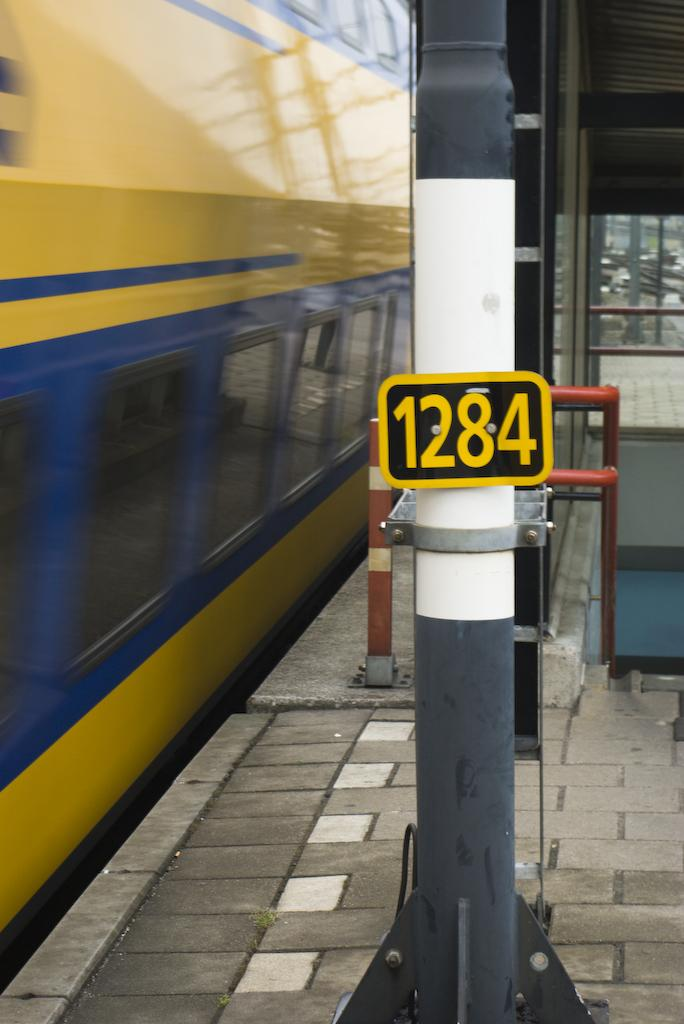<image>
Describe the image concisely. a pole that has 1284 on the side 